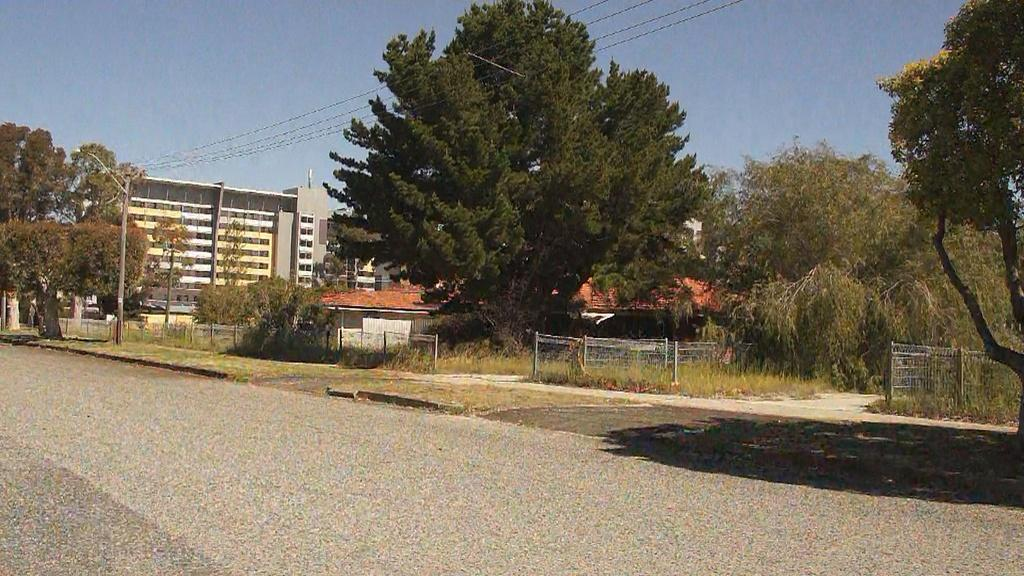What type of surface can be seen in the image? There is a road in the image. What type of vegetation is present in the image? There is grass and trees in the image. What structure can be seen in the image? There is a pole in the image. What is attached to the pole in the image? There is a light attached to the pole in the image. What type of barrier can be seen in the image? There are fences in the image. What can be seen in the background of the image? There are buildings and a house in the background of the image, as well as the sky. What type of bucket is being used by the band in the image? There is no band or bucket present in the image. What type of request can be seen written on the house in the image? There is no request written on the house in the image. 